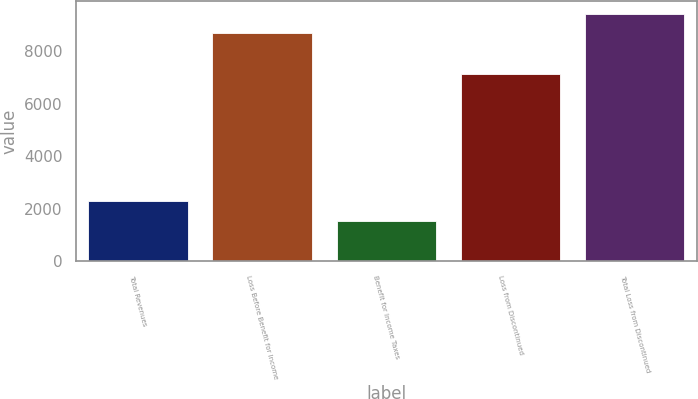Convert chart to OTSL. <chart><loc_0><loc_0><loc_500><loc_500><bar_chart><fcel>Total Revenues<fcel>Loss Before Benefit for Income<fcel>Benefit for Income Taxes<fcel>Loss from Discontinued<fcel>Total Loss from Discontinued<nl><fcel>2291.3<fcel>8692<fcel>1542<fcel>7150<fcel>9441.3<nl></chart> 